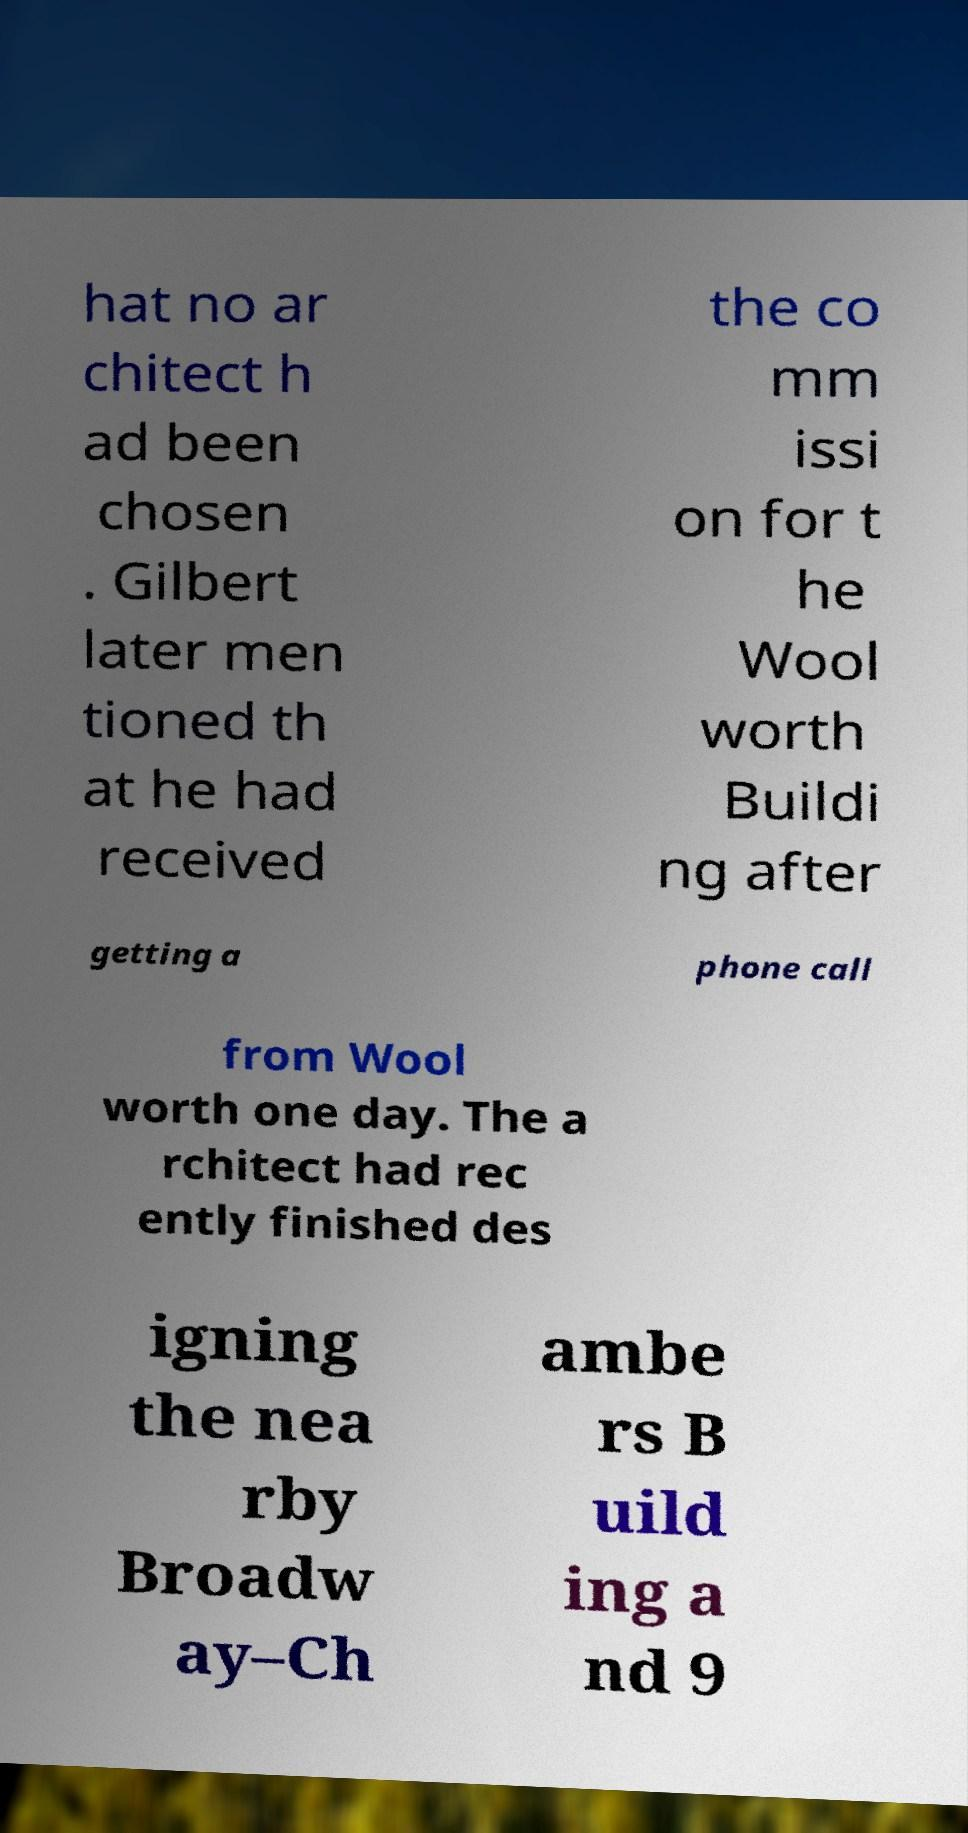For documentation purposes, I need the text within this image transcribed. Could you provide that? hat no ar chitect h ad been chosen . Gilbert later men tioned th at he had received the co mm issi on for t he Wool worth Buildi ng after getting a phone call from Wool worth one day. The a rchitect had rec ently finished des igning the nea rby Broadw ay–Ch ambe rs B uild ing a nd 9 